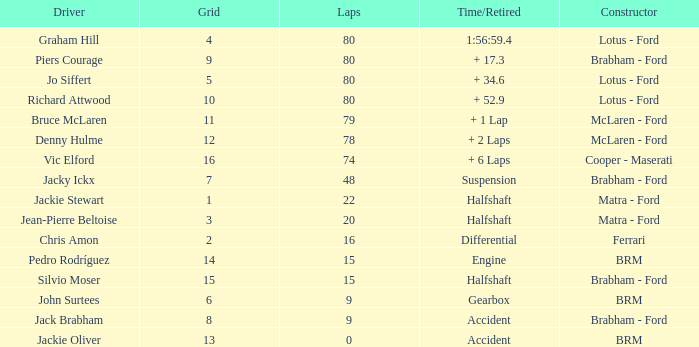What is the time/retired for brm with a grid of 13? Accident. 